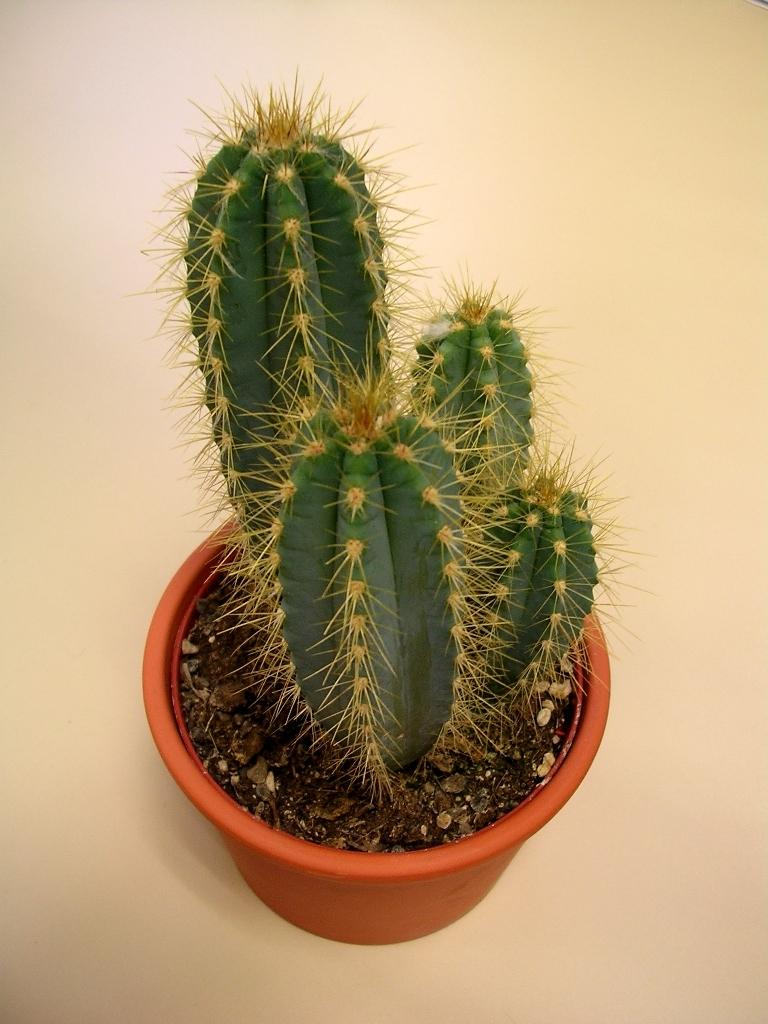What type of plant is in the image? There is a cactus plant in the image. How is the cactus plant contained or displayed? The cactus plant is in a pot. Where is the pot with the cactus plant located? The pot is placed on a surface. What value does the cactus plant have in the image? The value of the cactus plant cannot be determined from the image alone, as it is a subjective concept. 